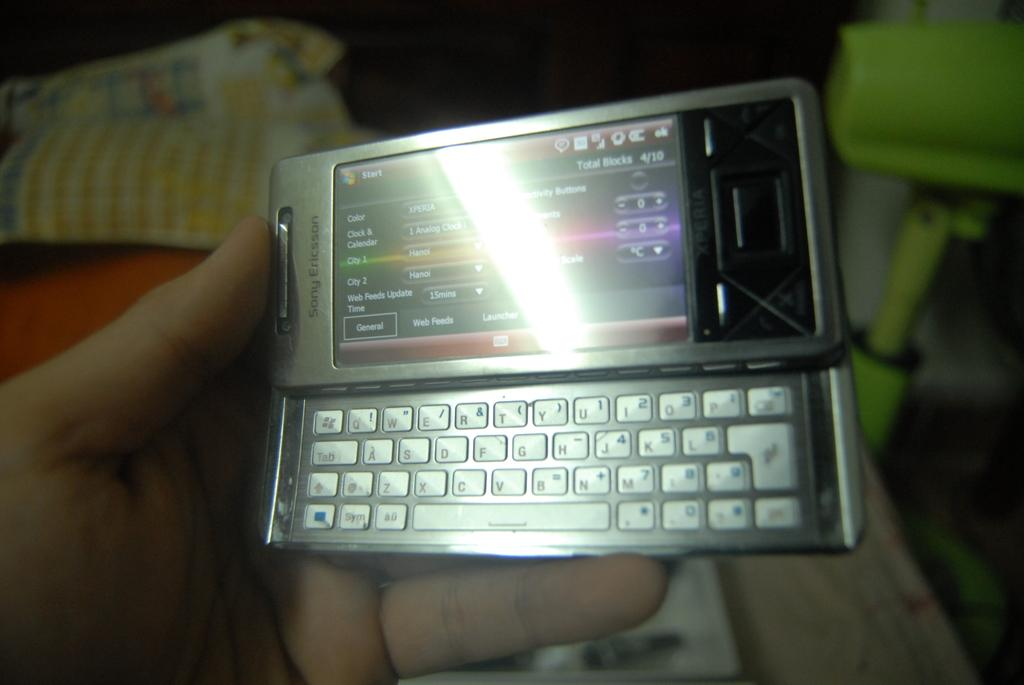What is the main subject of the image? There is a person in the image. What is the person doing with their hand? The person's hand is holding a mobile. What else can be seen in the image besides the person and the mobile? There are clothes and other objects in the image. Can you describe the background of the image? The background of the image is dark. What type of wheel can be seen in the image? There is no wheel present in the image. Does the person in the image express any feelings of hate? The image does not convey any emotions or feelings, so it cannot be determined if the person expresses hate. 